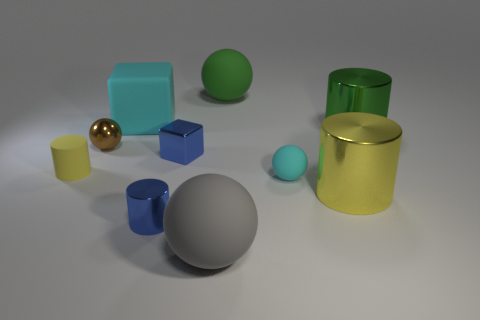Subtract all balls. How many objects are left? 6 Add 3 tiny cyan things. How many tiny cyan things are left? 4 Add 8 tiny green shiny blocks. How many tiny green shiny blocks exist? 8 Subtract 0 purple spheres. How many objects are left? 10 Subtract all brown matte objects. Subtract all big yellow objects. How many objects are left? 9 